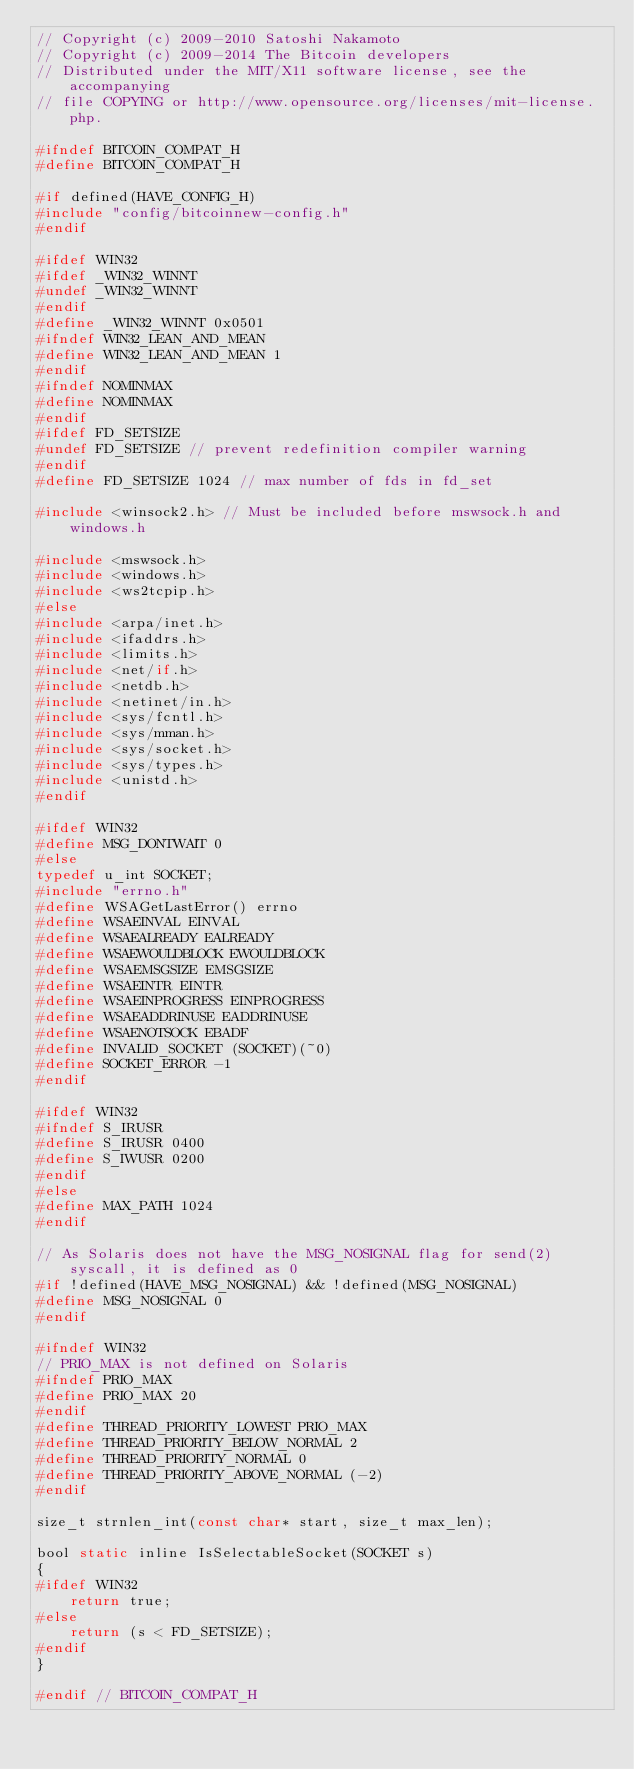Convert code to text. <code><loc_0><loc_0><loc_500><loc_500><_C_>// Copyright (c) 2009-2010 Satoshi Nakamoto
// Copyright (c) 2009-2014 The Bitcoin developers
// Distributed under the MIT/X11 software license, see the accompanying
// file COPYING or http://www.opensource.org/licenses/mit-license.php.

#ifndef BITCOIN_COMPAT_H
#define BITCOIN_COMPAT_H

#if defined(HAVE_CONFIG_H)
#include "config/bitcoinnew-config.h"
#endif

#ifdef WIN32
#ifdef _WIN32_WINNT
#undef _WIN32_WINNT
#endif
#define _WIN32_WINNT 0x0501
#ifndef WIN32_LEAN_AND_MEAN
#define WIN32_LEAN_AND_MEAN 1
#endif
#ifndef NOMINMAX
#define NOMINMAX
#endif
#ifdef FD_SETSIZE
#undef FD_SETSIZE // prevent redefinition compiler warning
#endif
#define FD_SETSIZE 1024 // max number of fds in fd_set

#include <winsock2.h> // Must be included before mswsock.h and windows.h

#include <mswsock.h>
#include <windows.h>
#include <ws2tcpip.h>
#else
#include <arpa/inet.h>
#include <ifaddrs.h>
#include <limits.h>
#include <net/if.h>
#include <netdb.h>
#include <netinet/in.h>
#include <sys/fcntl.h>
#include <sys/mman.h>
#include <sys/socket.h>
#include <sys/types.h>
#include <unistd.h>
#endif

#ifdef WIN32
#define MSG_DONTWAIT 0
#else
typedef u_int SOCKET;
#include "errno.h"
#define WSAGetLastError() errno
#define WSAEINVAL EINVAL
#define WSAEALREADY EALREADY
#define WSAEWOULDBLOCK EWOULDBLOCK
#define WSAEMSGSIZE EMSGSIZE
#define WSAEINTR EINTR
#define WSAEINPROGRESS EINPROGRESS
#define WSAEADDRINUSE EADDRINUSE
#define WSAENOTSOCK EBADF
#define INVALID_SOCKET (SOCKET)(~0)
#define SOCKET_ERROR -1
#endif

#ifdef WIN32
#ifndef S_IRUSR
#define S_IRUSR 0400
#define S_IWUSR 0200
#endif
#else
#define MAX_PATH 1024
#endif

// As Solaris does not have the MSG_NOSIGNAL flag for send(2) syscall, it is defined as 0
#if !defined(HAVE_MSG_NOSIGNAL) && !defined(MSG_NOSIGNAL)
#define MSG_NOSIGNAL 0
#endif

#ifndef WIN32
// PRIO_MAX is not defined on Solaris
#ifndef PRIO_MAX
#define PRIO_MAX 20
#endif
#define THREAD_PRIORITY_LOWEST PRIO_MAX
#define THREAD_PRIORITY_BELOW_NORMAL 2
#define THREAD_PRIORITY_NORMAL 0
#define THREAD_PRIORITY_ABOVE_NORMAL (-2)
#endif

size_t strnlen_int(const char* start, size_t max_len);

bool static inline IsSelectableSocket(SOCKET s)
{
#ifdef WIN32
    return true;
#else
    return (s < FD_SETSIZE);
#endif
}

#endif // BITCOIN_COMPAT_H
</code> 